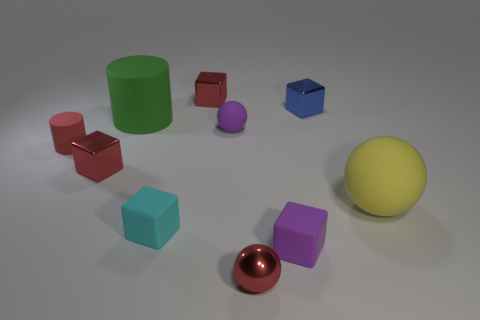Describe the texture and lighting of the scene. The objects in the image have a matte finish with soft shadows, indicating diffuse lighting in the scene. The light source seems to come from the upper left side, as indicated by the shadows cast to the right of the objects. The scene overall has a calm, soft quality to it. 